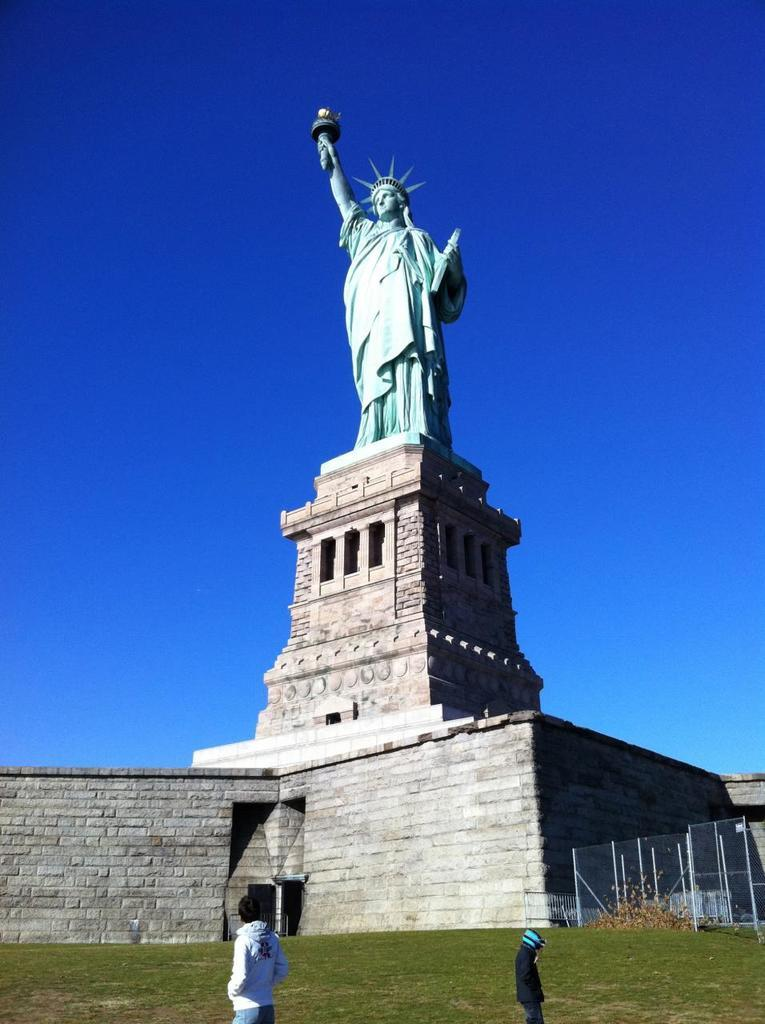What is the main subject in the image? There is a statue in the image. Are there any other elements in the image besides the statue? Yes, there are people standing in the image. What is the color of the sky in the image? The sky is blue in the image. What type of barrier can be seen in the image? There is a metal fence on the side in the image. What type of rhythm can be heard coming from the laborer in the image? There is no laborer present in the image, and therefore no rhythm can be heard. 